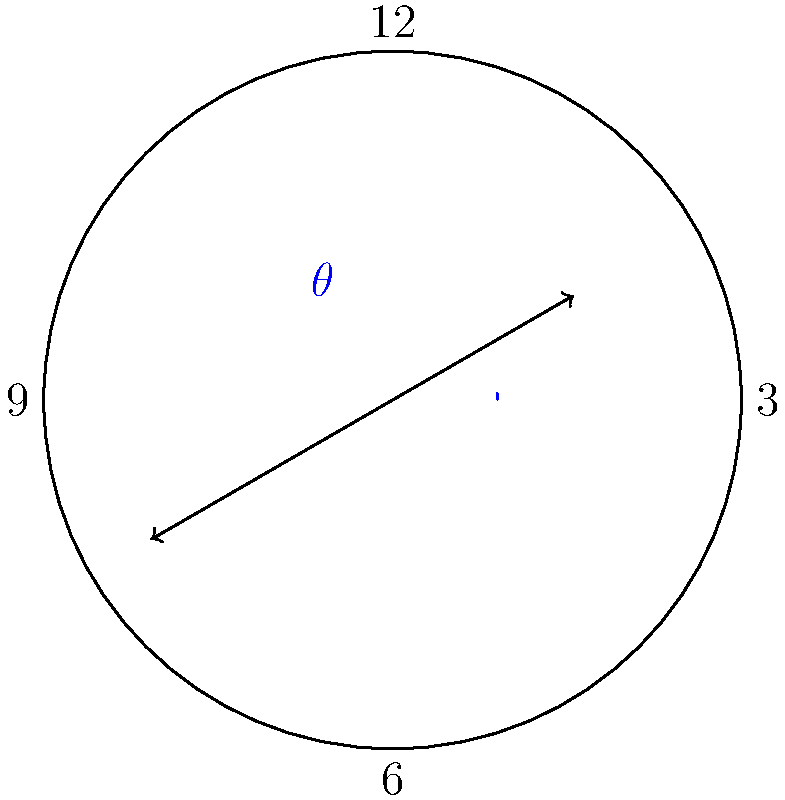In the spirit of philosophical inquiry about the nature of time and measurement, consider a clock showing 2:35. What is the measure of the acute angle $\theta$ formed between the hour and minute hands? Let's approach this step-by-step, considering the movement of both hands:

1) In a 12-hour clock, the hour hand makes a complete 360° rotation in 12 hours, so it moves at a rate of 360° / 12 = 30° per hour, or 0.5° per minute.

2) The minute hand makes a complete 360° rotation in 60 minutes, so it moves at a rate of 360° / 60 = 6° per minute.

3) At 2:35:
   - The hour hand has moved from the 2 o'clock position by: 35 * 0.5° = 17.5°
   - So the hour hand is at: 2 * 30° + 17.5° = 77.5° from the 12 o'clock position
   - The minute hand is at: 35 * 6° = 210° from the 12 o'clock position

4) The angle between the hands is: 210° - 77.5° = 132.5°

5) However, the question asks for the acute angle. The acute angle is the smaller of the two angles formed, so we need to subtract this from 180°:

   180° - 132.5° = 47.5°

Thus, the acute angle between the hour and minute hands at 2:35 is 47.5°.

This problem illustrates how we can use mathematical reasoning to analyze everyday phenomena, bridging the gap between abstract concepts and real-world applications - a common theme in philosophical discussions about mathematics and reality.
Answer: 47.5° 